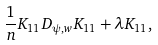Convert formula to latex. <formula><loc_0><loc_0><loc_500><loc_500>\frac { 1 } { n } K _ { 1 1 } D _ { \psi , w } K _ { 1 1 } + \lambda K _ { 1 1 } ,</formula> 